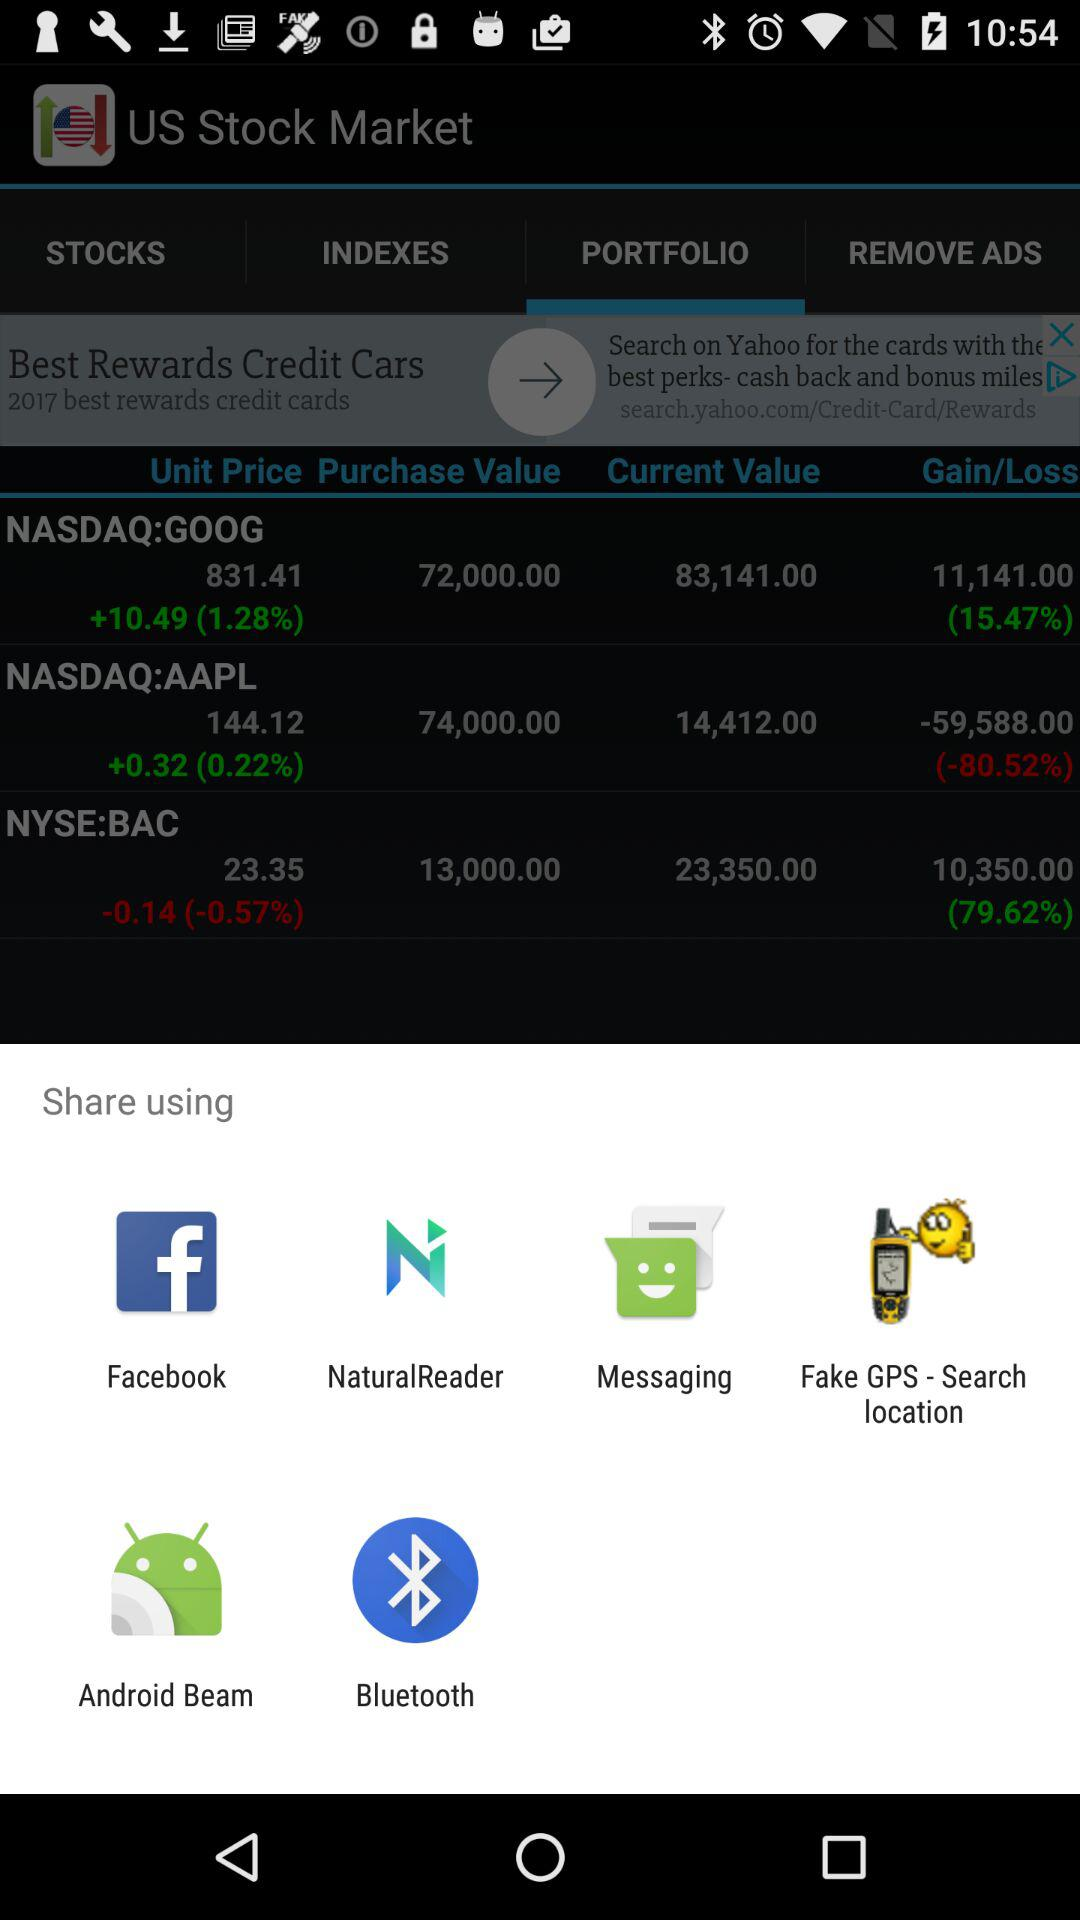Which applications can be used to share? The applications that can be used to share are "Facebook", "NaturalReader", "Messaging", "Fake GPS - Search location", "Android Beam" and "Bluetooth". 